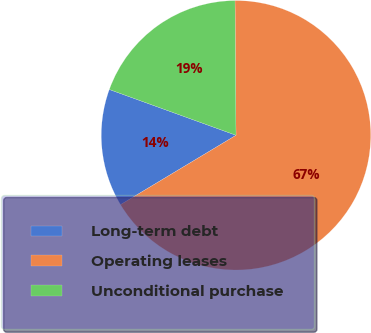<chart> <loc_0><loc_0><loc_500><loc_500><pie_chart><fcel>Long-term debt<fcel>Operating leases<fcel>Unconditional purchase<nl><fcel>14.13%<fcel>66.51%<fcel>19.36%<nl></chart> 